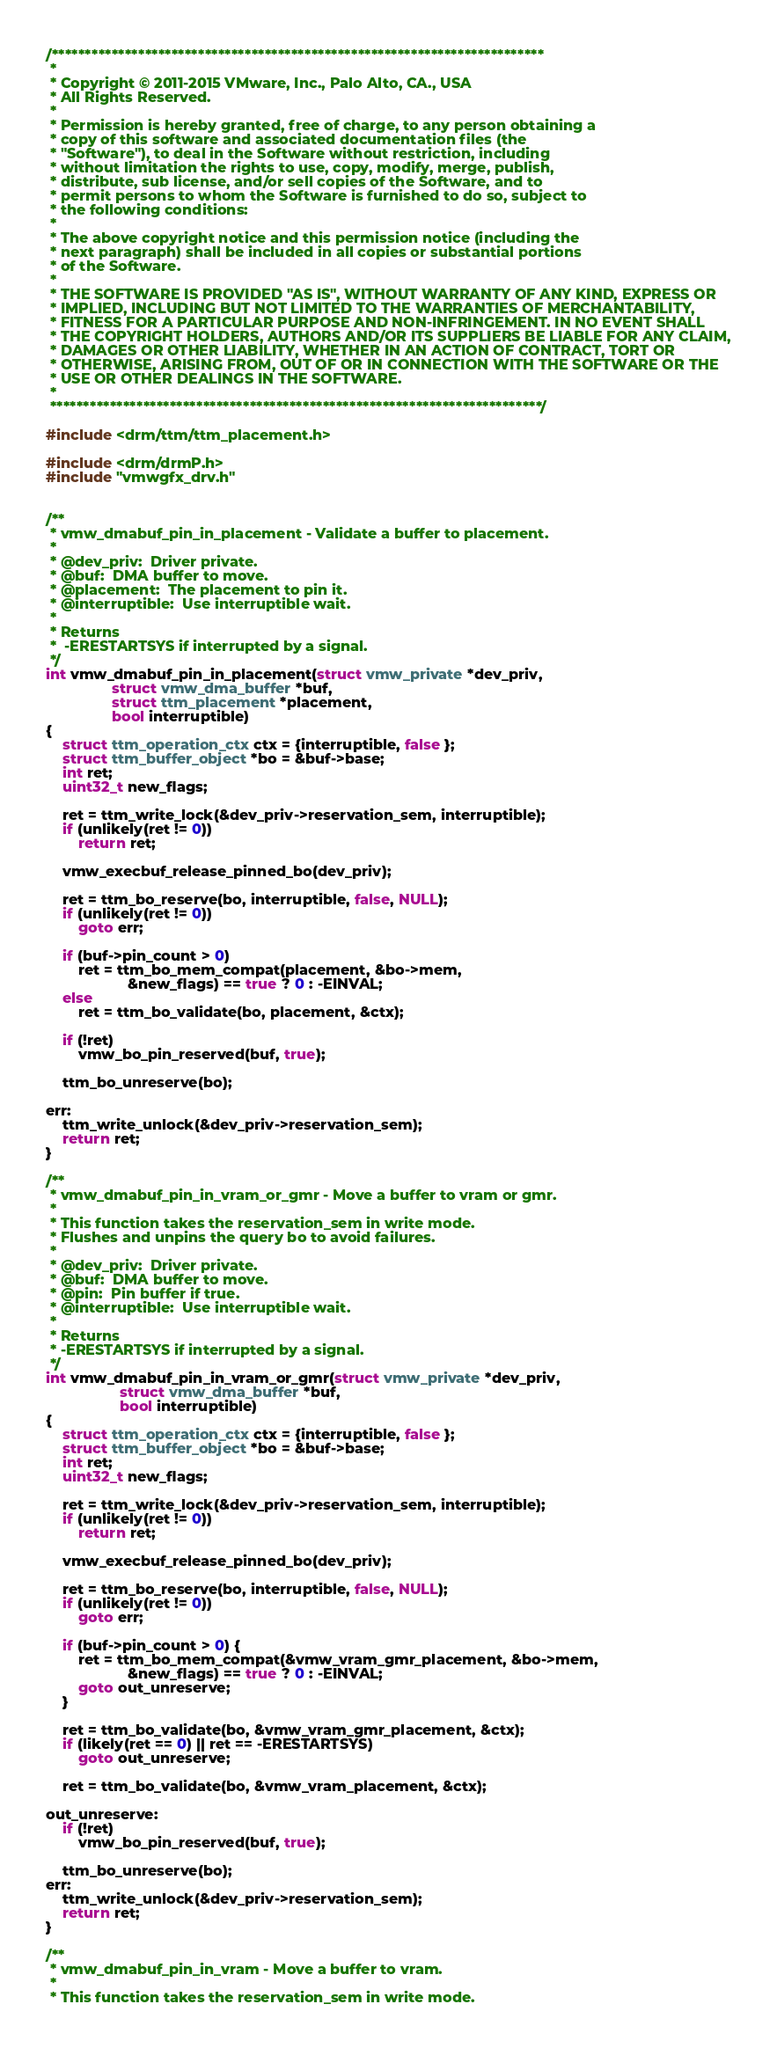Convert code to text. <code><loc_0><loc_0><loc_500><loc_500><_C_>/**************************************************************************
 *
 * Copyright © 2011-2015 VMware, Inc., Palo Alto, CA., USA
 * All Rights Reserved.
 *
 * Permission is hereby granted, free of charge, to any person obtaining a
 * copy of this software and associated documentation files (the
 * "Software"), to deal in the Software without restriction, including
 * without limitation the rights to use, copy, modify, merge, publish,
 * distribute, sub license, and/or sell copies of the Software, and to
 * permit persons to whom the Software is furnished to do so, subject to
 * the following conditions:
 *
 * The above copyright notice and this permission notice (including the
 * next paragraph) shall be included in all copies or substantial portions
 * of the Software.
 *
 * THE SOFTWARE IS PROVIDED "AS IS", WITHOUT WARRANTY OF ANY KIND, EXPRESS OR
 * IMPLIED, INCLUDING BUT NOT LIMITED TO THE WARRANTIES OF MERCHANTABILITY,
 * FITNESS FOR A PARTICULAR PURPOSE AND NON-INFRINGEMENT. IN NO EVENT SHALL
 * THE COPYRIGHT HOLDERS, AUTHORS AND/OR ITS SUPPLIERS BE LIABLE FOR ANY CLAIM,
 * DAMAGES OR OTHER LIABILITY, WHETHER IN AN ACTION OF CONTRACT, TORT OR
 * OTHERWISE, ARISING FROM, OUT OF OR IN CONNECTION WITH THE SOFTWARE OR THE
 * USE OR OTHER DEALINGS IN THE SOFTWARE.
 *
 **************************************************************************/

#include <drm/ttm/ttm_placement.h>

#include <drm/drmP.h>
#include "vmwgfx_drv.h"


/**
 * vmw_dmabuf_pin_in_placement - Validate a buffer to placement.
 *
 * @dev_priv:  Driver private.
 * @buf:  DMA buffer to move.
 * @placement:  The placement to pin it.
 * @interruptible:  Use interruptible wait.
 *
 * Returns
 *  -ERESTARTSYS if interrupted by a signal.
 */
int vmw_dmabuf_pin_in_placement(struct vmw_private *dev_priv,
				struct vmw_dma_buffer *buf,
				struct ttm_placement *placement,
				bool interruptible)
{
	struct ttm_operation_ctx ctx = {interruptible, false };
	struct ttm_buffer_object *bo = &buf->base;
	int ret;
	uint32_t new_flags;

	ret = ttm_write_lock(&dev_priv->reservation_sem, interruptible);
	if (unlikely(ret != 0))
		return ret;

	vmw_execbuf_release_pinned_bo(dev_priv);

	ret = ttm_bo_reserve(bo, interruptible, false, NULL);
	if (unlikely(ret != 0))
		goto err;

	if (buf->pin_count > 0)
		ret = ttm_bo_mem_compat(placement, &bo->mem,
					&new_flags) == true ? 0 : -EINVAL;
	else
		ret = ttm_bo_validate(bo, placement, &ctx);

	if (!ret)
		vmw_bo_pin_reserved(buf, true);

	ttm_bo_unreserve(bo);

err:
	ttm_write_unlock(&dev_priv->reservation_sem);
	return ret;
}

/**
 * vmw_dmabuf_pin_in_vram_or_gmr - Move a buffer to vram or gmr.
 *
 * This function takes the reservation_sem in write mode.
 * Flushes and unpins the query bo to avoid failures.
 *
 * @dev_priv:  Driver private.
 * @buf:  DMA buffer to move.
 * @pin:  Pin buffer if true.
 * @interruptible:  Use interruptible wait.
 *
 * Returns
 * -ERESTARTSYS if interrupted by a signal.
 */
int vmw_dmabuf_pin_in_vram_or_gmr(struct vmw_private *dev_priv,
				  struct vmw_dma_buffer *buf,
				  bool interruptible)
{
	struct ttm_operation_ctx ctx = {interruptible, false };
	struct ttm_buffer_object *bo = &buf->base;
	int ret;
	uint32_t new_flags;

	ret = ttm_write_lock(&dev_priv->reservation_sem, interruptible);
	if (unlikely(ret != 0))
		return ret;

	vmw_execbuf_release_pinned_bo(dev_priv);

	ret = ttm_bo_reserve(bo, interruptible, false, NULL);
	if (unlikely(ret != 0))
		goto err;

	if (buf->pin_count > 0) {
		ret = ttm_bo_mem_compat(&vmw_vram_gmr_placement, &bo->mem,
					&new_flags) == true ? 0 : -EINVAL;
		goto out_unreserve;
	}

	ret = ttm_bo_validate(bo, &vmw_vram_gmr_placement, &ctx);
	if (likely(ret == 0) || ret == -ERESTARTSYS)
		goto out_unreserve;

	ret = ttm_bo_validate(bo, &vmw_vram_placement, &ctx);

out_unreserve:
	if (!ret)
		vmw_bo_pin_reserved(buf, true);

	ttm_bo_unreserve(bo);
err:
	ttm_write_unlock(&dev_priv->reservation_sem);
	return ret;
}

/**
 * vmw_dmabuf_pin_in_vram - Move a buffer to vram.
 *
 * This function takes the reservation_sem in write mode.</code> 